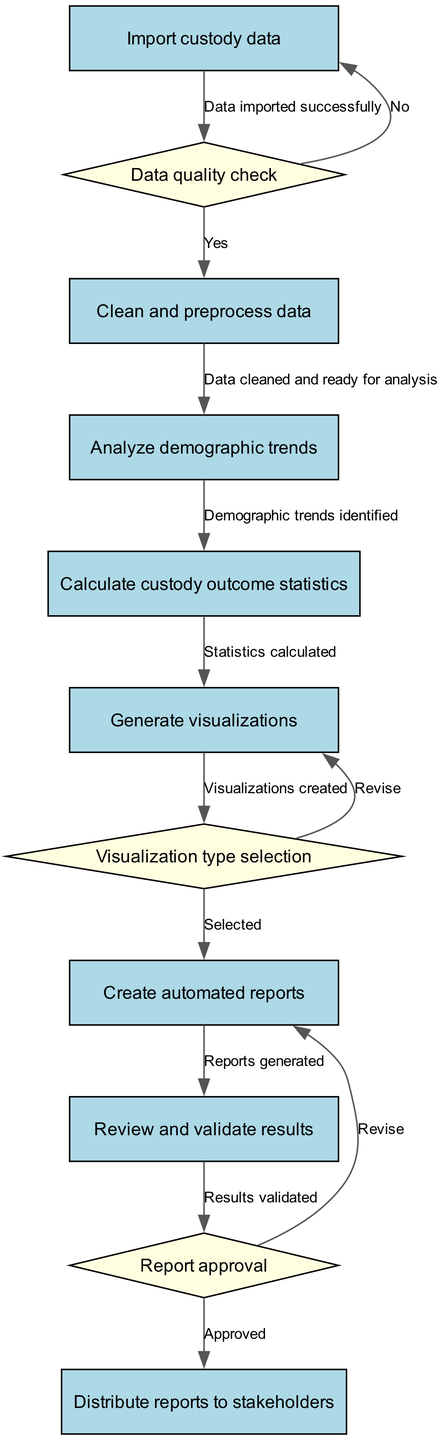What is the first node in the diagram? The first node mentioned in the diagram is "Import custody data". This is the starting point of the activity flow as per the nodes presented.
Answer: Import custody data How many decision nodes are there in the diagram? The diagram has three decision nodes. These decision nodes occur after specific activities where choices need to be made.
Answer: 3 What follows after the "Analyze demographic trends" node? After the "Analyze demographic trends" node, the next node is "Calculate custody outcome statistics". This shows the flow from trend analysis to the calculation of outcomes.
Answer: Calculate custody outcome statistics What is the outcome if data fails quality check? If the data fails the quality check, the flow would not proceed to the next node ("Clean and preprocess data"), as indicated by the decision node leading back to the first node instead of moving forward.
Answer: Go back to "Import custody data" What type of report is created at the end of the pipeline? The final report created at the end of the pipeline is "Create automated reports". This indicates that the reporting is done automatically based on previous analyses.
Answer: Create automated reports What is the last action taken in this pipeline? The last action in the pipeline is "Distribute reports to stakeholders". This indicates the final step where the generated reports are shared with concerned parties.
Answer: Distribute reports to stakeholders Which node involves the selection of visualization types? The node that involves the selection of visualization types is "Visualization type selection". It specifies that a decision regarding how to visualize the data will be made.
Answer: Visualization type selection What is needed before generating reports? Before generating reports, it is necessary to "Review and validate results". This step ensures that the analysis and outcomes are accurate before distribution.
Answer: Review and validate results What happens if the report is not approved? If the report is not approved, the flow returns to the node "Create automated reports", indicating that the report will be revised before being finalized for distribution.
Answer: Revise 